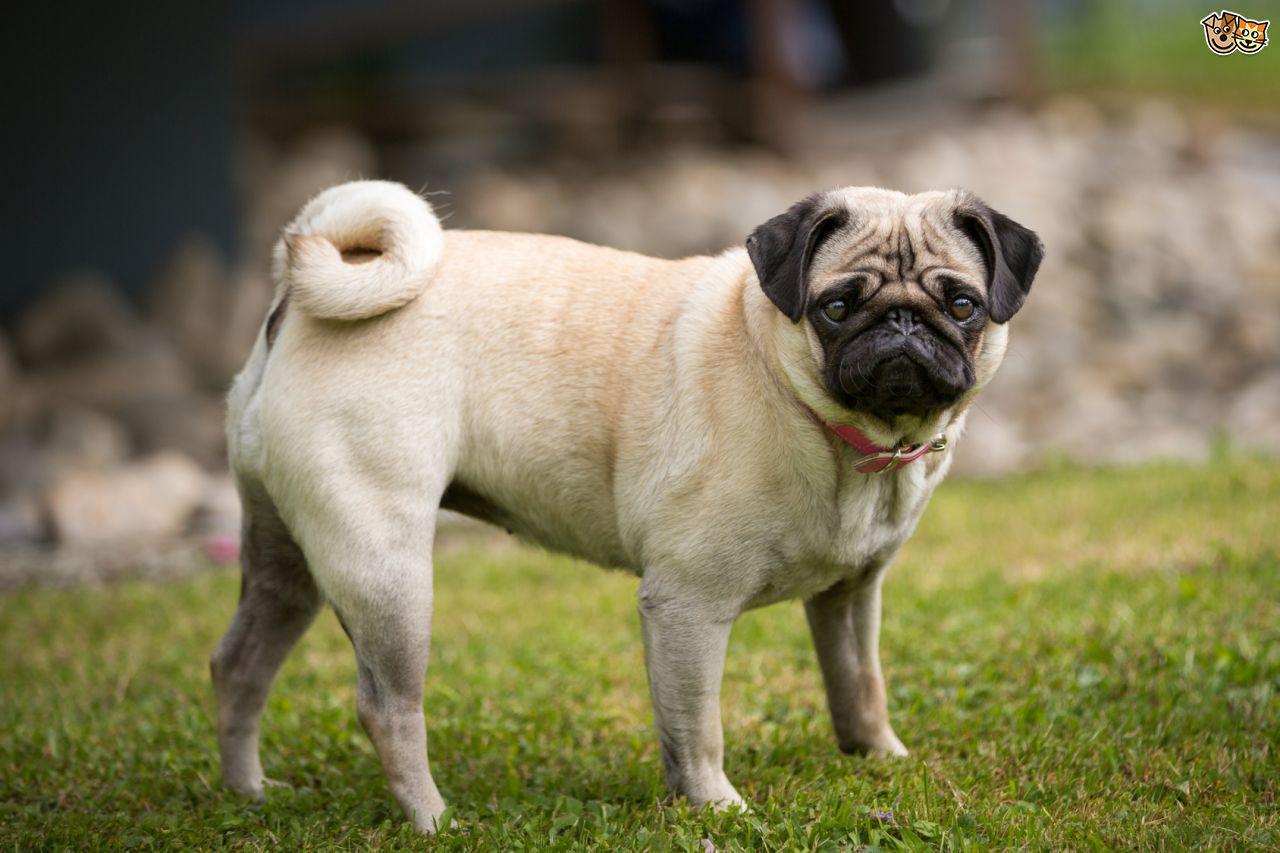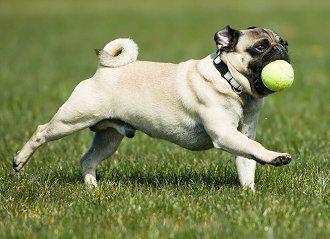The first image is the image on the left, the second image is the image on the right. Analyze the images presented: Is the assertion "A small dark-faced dog has a stick in its mouth and is standing in a field." valid? Answer yes or no. No. 